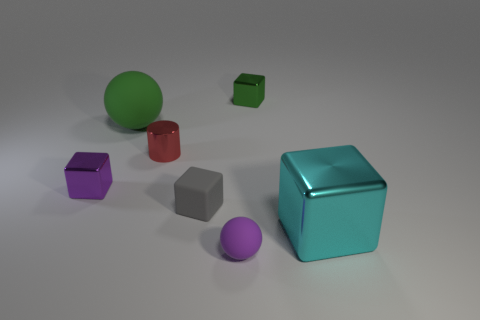How many big things are on the left side of the cyan cube and in front of the small gray rubber block?
Your answer should be very brief. 0. The other purple sphere that is made of the same material as the big sphere is what size?
Give a very brief answer. Small. The red metallic object has what size?
Your response must be concise. Small. What is the material of the purple cube?
Keep it short and to the point. Metal. Do the ball that is behind the purple ball and the tiny red metallic cylinder have the same size?
Your answer should be very brief. No. What number of objects are either tiny rubber balls or green things?
Ensure brevity in your answer.  3. There is a small object that is the same color as the large rubber object; what shape is it?
Provide a short and direct response. Cube. What size is the metallic block that is on the left side of the large block and on the right side of the purple cube?
Offer a very short reply. Small. How many big red matte blocks are there?
Your response must be concise. 0. How many cylinders are either tiny green shiny objects or big objects?
Keep it short and to the point. 0. 